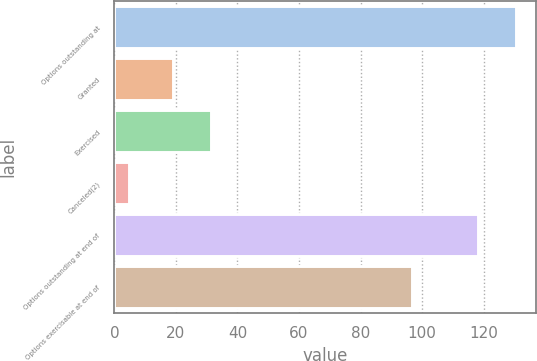Convert chart. <chart><loc_0><loc_0><loc_500><loc_500><bar_chart><fcel>Options outstanding at<fcel>Granted<fcel>Exercised<fcel>Canceled(2)<fcel>Options outstanding at end of<fcel>Options exercisable at end of<nl><fcel>130.49<fcel>18.9<fcel>31.29<fcel>4.7<fcel>118.1<fcel>96.7<nl></chart> 